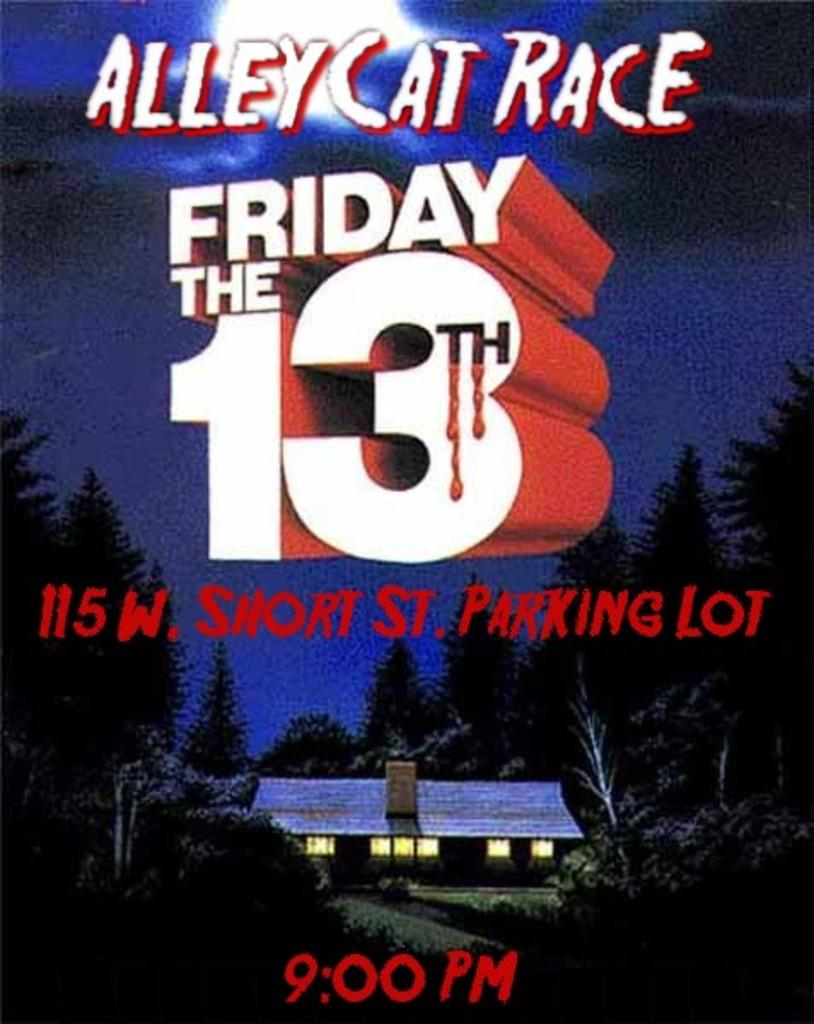<image>
Provide a brief description of the given image. A poster advertising Friday the 13th Alley Cat Race. 